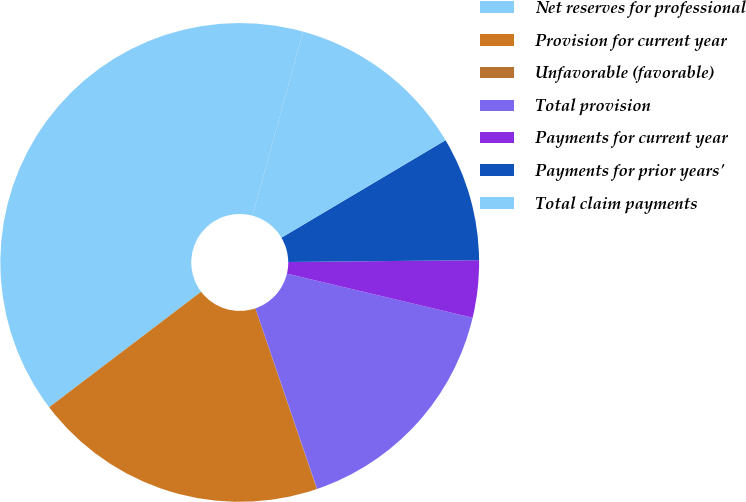Convert chart. <chart><loc_0><loc_0><loc_500><loc_500><pie_chart><fcel>Net reserves for professional<fcel>Provision for current year<fcel>Unfavorable (favorable)<fcel>Total provision<fcel>Payments for current year<fcel>Payments for prior years'<fcel>Total claim payments<nl><fcel>39.6%<fcel>19.88%<fcel>0.02%<fcel>16.05%<fcel>3.86%<fcel>8.38%<fcel>12.21%<nl></chart> 